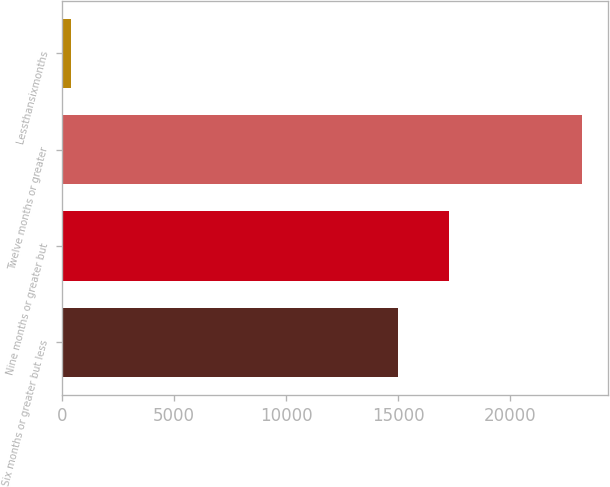Convert chart to OTSL. <chart><loc_0><loc_0><loc_500><loc_500><bar_chart><fcel>Six months or greater but less<fcel>Nine months or greater but<fcel>Twelve months or greater<fcel>Lessthansixmonths<nl><fcel>14975<fcel>17255.5<fcel>23191<fcel>386<nl></chart> 